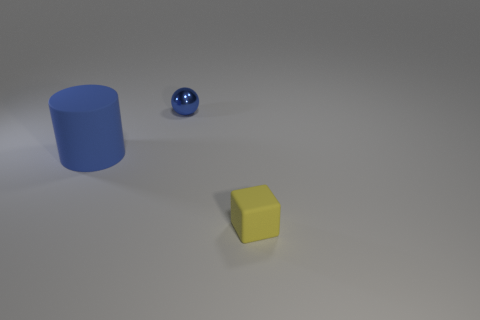Are there any other things that are the same material as the small ball?
Offer a terse response. No. What is the shape of the tiny metallic object that is the same color as the big thing?
Your response must be concise. Sphere. There is a rubber object to the left of the small yellow thing; does it have the same shape as the tiny yellow thing that is to the right of the ball?
Make the answer very short. No. Are there any blue shiny balls left of the tiny thing that is left of the yellow block?
Your answer should be very brief. No. Are any shiny balls visible?
Your response must be concise. Yes. What number of yellow blocks have the same size as the blue ball?
Provide a short and direct response. 1. What number of things are in front of the blue metallic ball and to the right of the blue matte thing?
Give a very brief answer. 1. There is a rubber object that is on the right side of the metal thing; does it have the same size as the tiny blue metallic sphere?
Offer a terse response. Yes. Are there any big cylinders of the same color as the tiny ball?
Your answer should be compact. Yes. What is the size of the yellow object that is the same material as the big blue cylinder?
Your response must be concise. Small. 